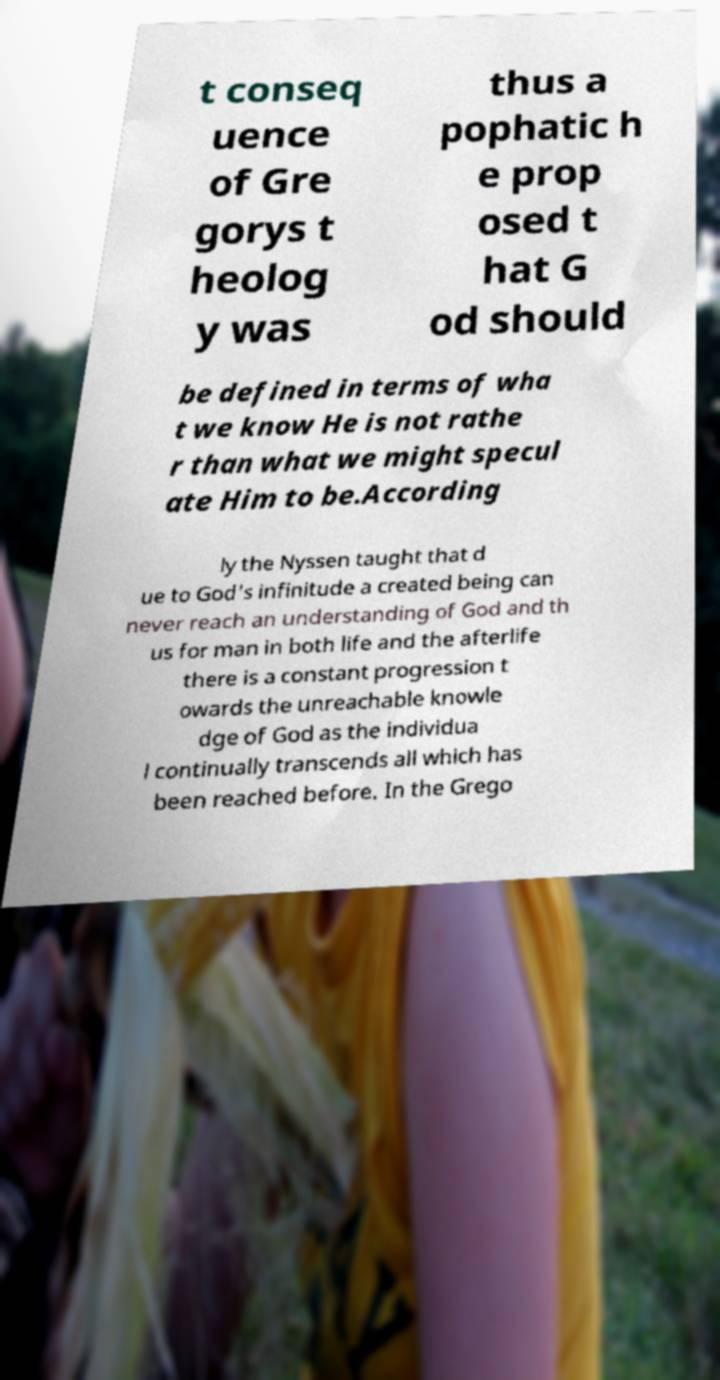For documentation purposes, I need the text within this image transcribed. Could you provide that? t conseq uence of Gre gorys t heolog y was thus a pophatic h e prop osed t hat G od should be defined in terms of wha t we know He is not rathe r than what we might specul ate Him to be.According ly the Nyssen taught that d ue to God's infinitude a created being can never reach an understanding of God and th us for man in both life and the afterlife there is a constant progression t owards the unreachable knowle dge of God as the individua l continually transcends all which has been reached before. In the Grego 